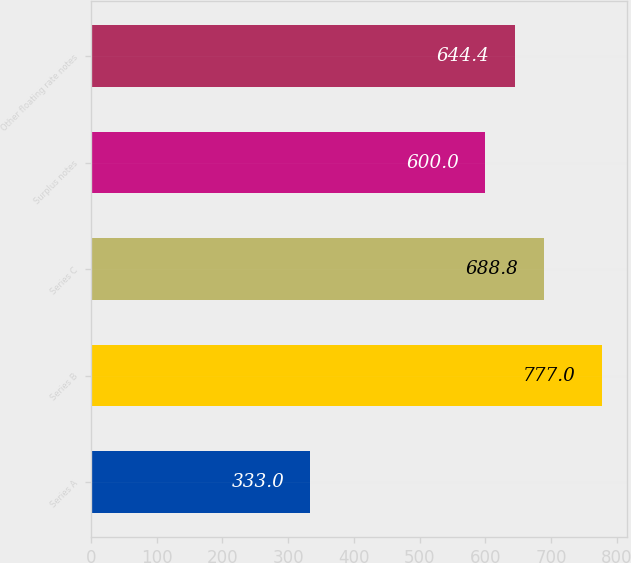Convert chart. <chart><loc_0><loc_0><loc_500><loc_500><bar_chart><fcel>Series A<fcel>Series B<fcel>Series C<fcel>Surplus notes<fcel>Other floating rate notes<nl><fcel>333<fcel>777<fcel>688.8<fcel>600<fcel>644.4<nl></chart> 